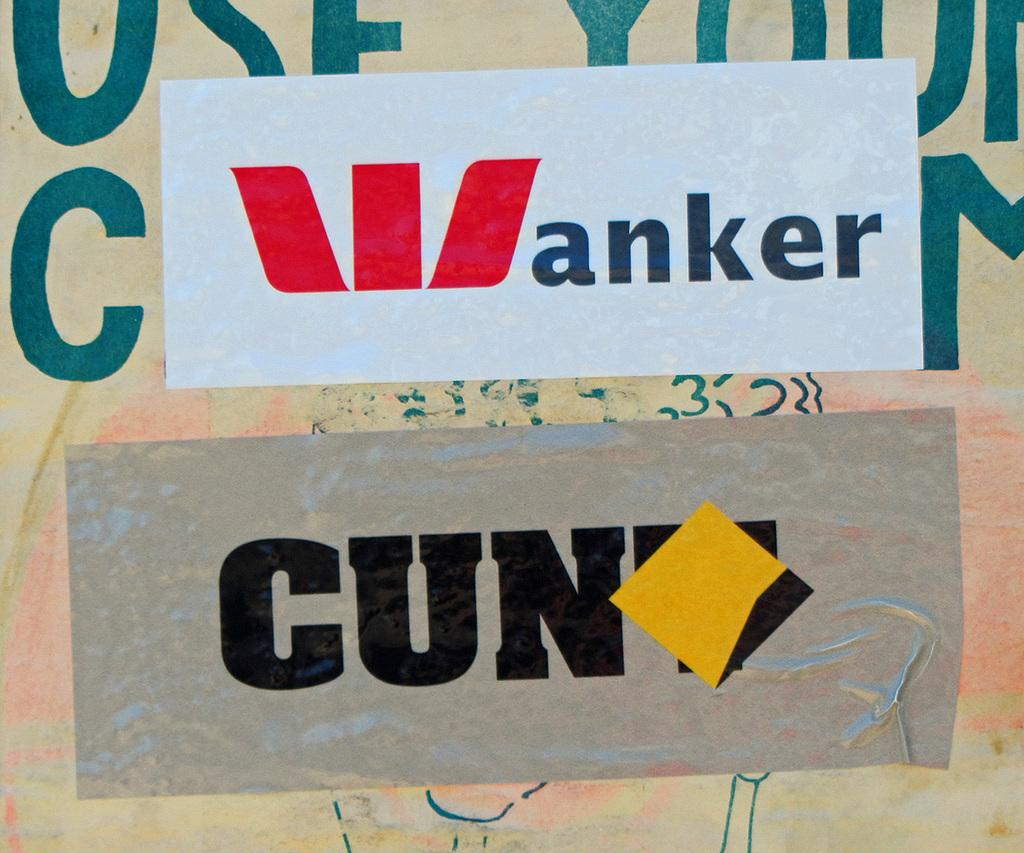What is present on the wall in the image? There is a wall in the image, and there are two posters on it. What can be seen on the wall besides the posters? There is text on the wall. What is written on the posters? The posters have text on them. What type of instrument is being played in the image? There is no instrument present in the image; it only features a wall with text and posters. What color are the teeth of the person in the image? There are no teeth or people visible in the image. 